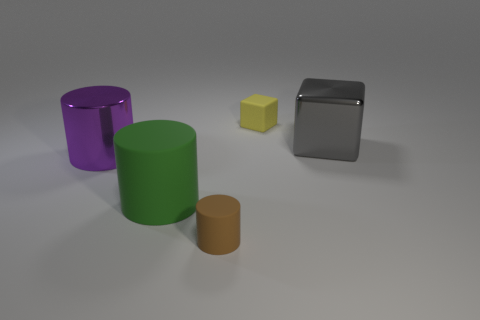Add 1 tiny gray rubber cylinders. How many objects exist? 6 Subtract all cylinders. How many objects are left? 2 Subtract all gray shiny things. Subtract all big purple spheres. How many objects are left? 4 Add 3 small yellow things. How many small yellow things are left? 4 Add 2 green cylinders. How many green cylinders exist? 3 Subtract 1 green cylinders. How many objects are left? 4 